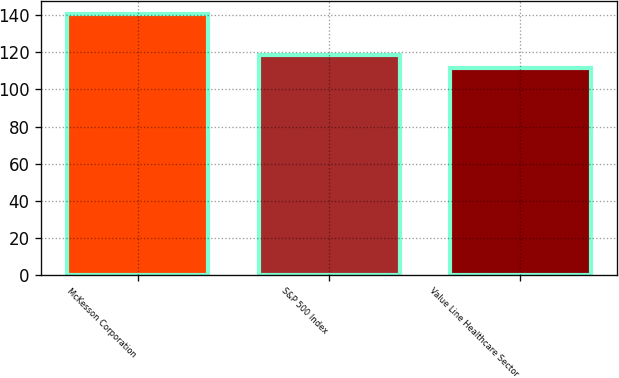Convert chart. <chart><loc_0><loc_0><loc_500><loc_500><bar_chart><fcel>McKesson Corporation<fcel>S&P 500 Index<fcel>Value Line Healthcare Sector<nl><fcel>140.65<fcel>118.6<fcel>111.76<nl></chart> 